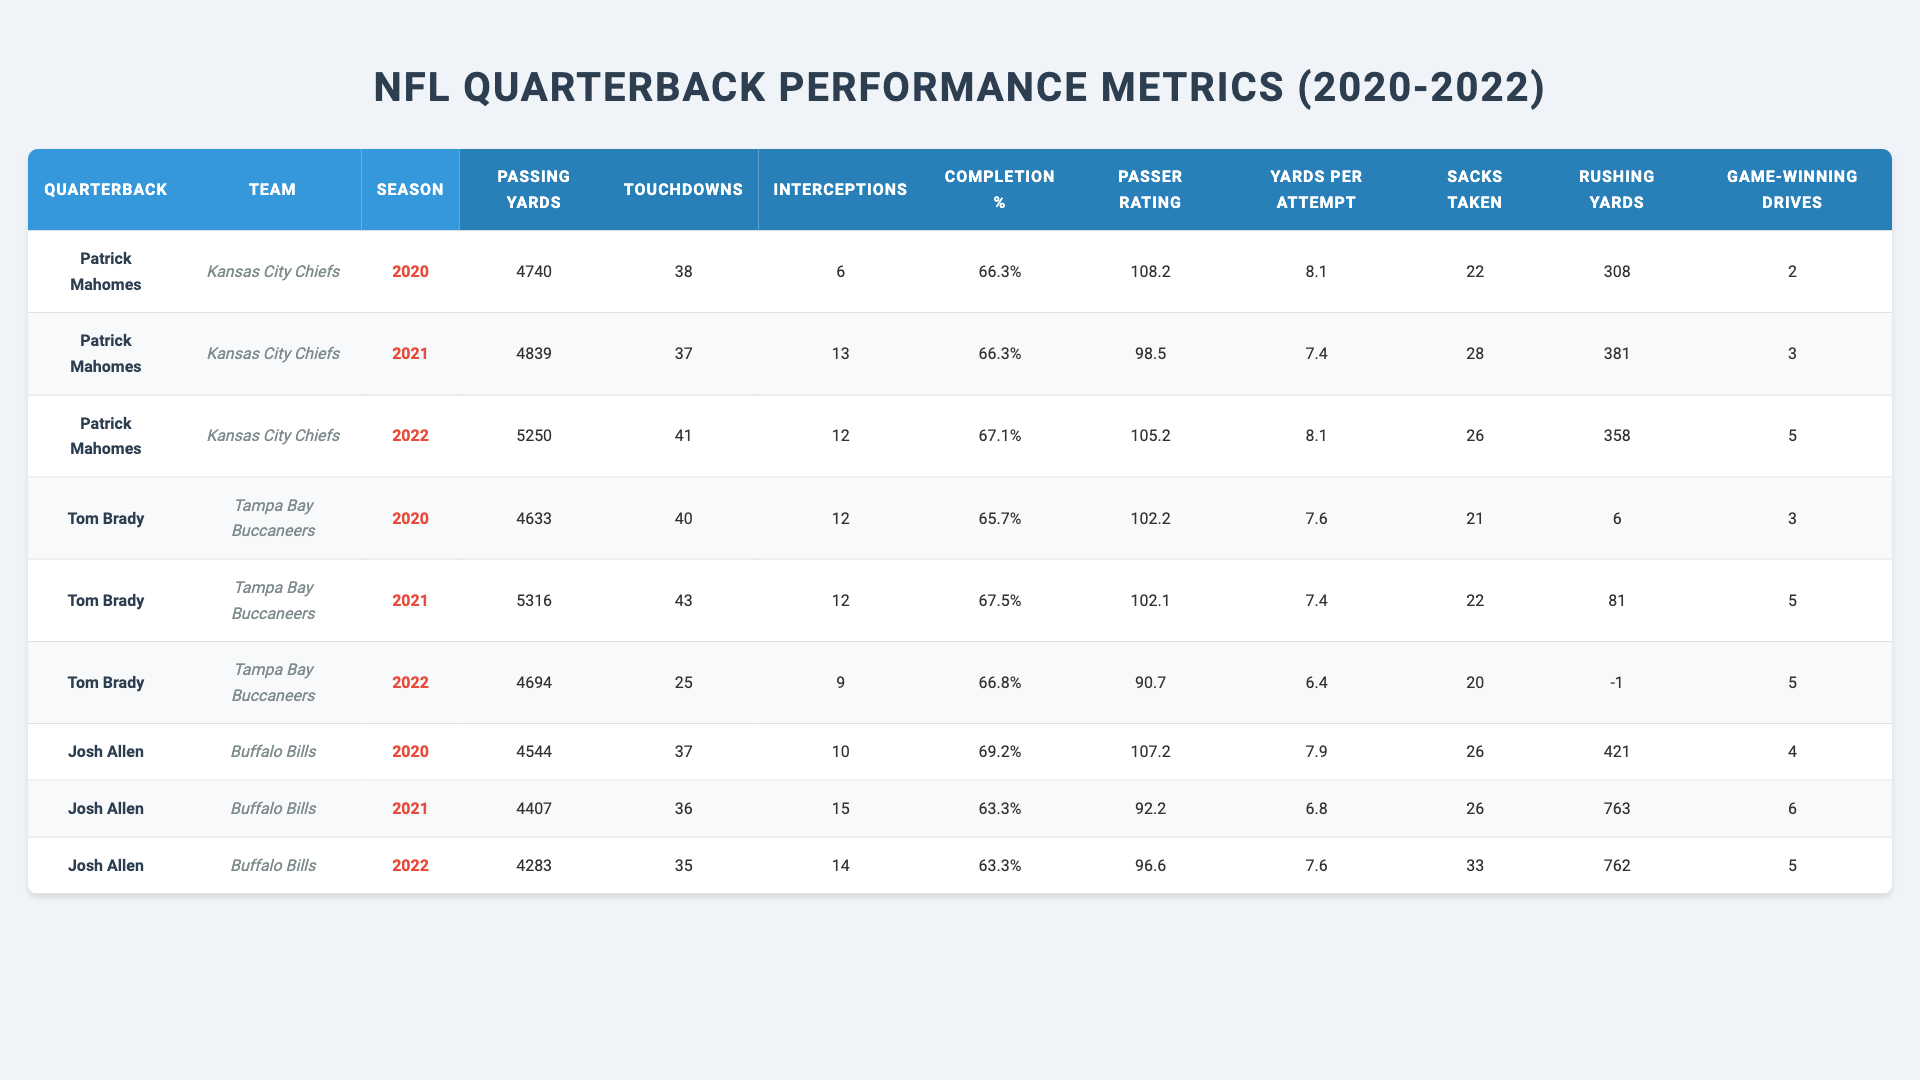What was Patrick Mahomes' highest number of passing yards in a season? Looking at the data, Patrick Mahomes recorded 5250 passing yards in the 2022 season, which is the highest among his seasons listed.
Answer: 5250 Which quarterback had the most touchdowns in the 2021 season? In the 2021 season, Tom Brady had the most touchdowns, throwing 43 touchdowns for the Tampa Bay Buccaneers.
Answer: 43 What is the average completion percentage for Josh Allen over the three seasons? Josh Allen's completion percentages are 69.2%, 63.3%, and 63.3%. The average is calculated as (69.2 + 63.3 + 63.3) / 3 = 65.3333, which can be rounded to 65.3%.
Answer: 65.3% Did Tom Brady throw more touchdowns than Patrick Mahomes in the 2020 season? In 2020, Tom Brady threw 40 touchdowns, while Patrick Mahomes threw 38 touchdowns. Since 40 is greater than 38, the answer is yes.
Answer: Yes Which quarterback had the highest passer rating in the 2020 season? The passer ratings for the 2020 season are Patrick Mahomes at 108.2 and Tom Brady at 102.2. Mahomes has the highest rating at 108.2.
Answer: 108.2 How many game-winning drives did Patrick Mahomes have in total over the three seasons? Summing Mahomes' game-winning drives: 2 (2020) + 3 (2021) + 5 (2022) = 10 game-winning drives in total.
Answer: 10 Did Josh Allen have more rushing yards or passing yards in the 2021 season? In the 2021 season, Josh Allen had 4407 passing yards and 763 rushing yards. Since 763 is greater than 4407, the answer is the rushing yards were fewer.
Answer: Fewer Which player had the most interceptions in 2021? In 2021, Josh Allen had 15 interceptions, which is higher than any other player that season.
Answer: 15 How many total passing yards did Tom Brady accumulate over the three seasons? Brady's passing yards are 4633 (2020) + 5316 (2021) + 4694 (2022) = 14643 total passing yards over the three seasons.
Answer: 14643 Which quarterback had the fewest sacks taken in 2020? In 2020, Tom Brady took 21 sacks while Patrick Mahomes took 22 and Josh Allen took 26. Tom Brady had the fewest sacks taken that season.
Answer: 21 Which quarterback consistently had the highest completion percentage across the three seasons? Analyzing the completion percentages: Mahomes: 66.3, 66.3, 67.1; Brady: 65.7, 67.5, 66.8; Allen: 69.2, 63.3, 63.3. Josh Allen had the highest at 69.2% in 2020.
Answer: Josh Allen (2020) 